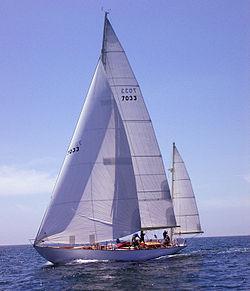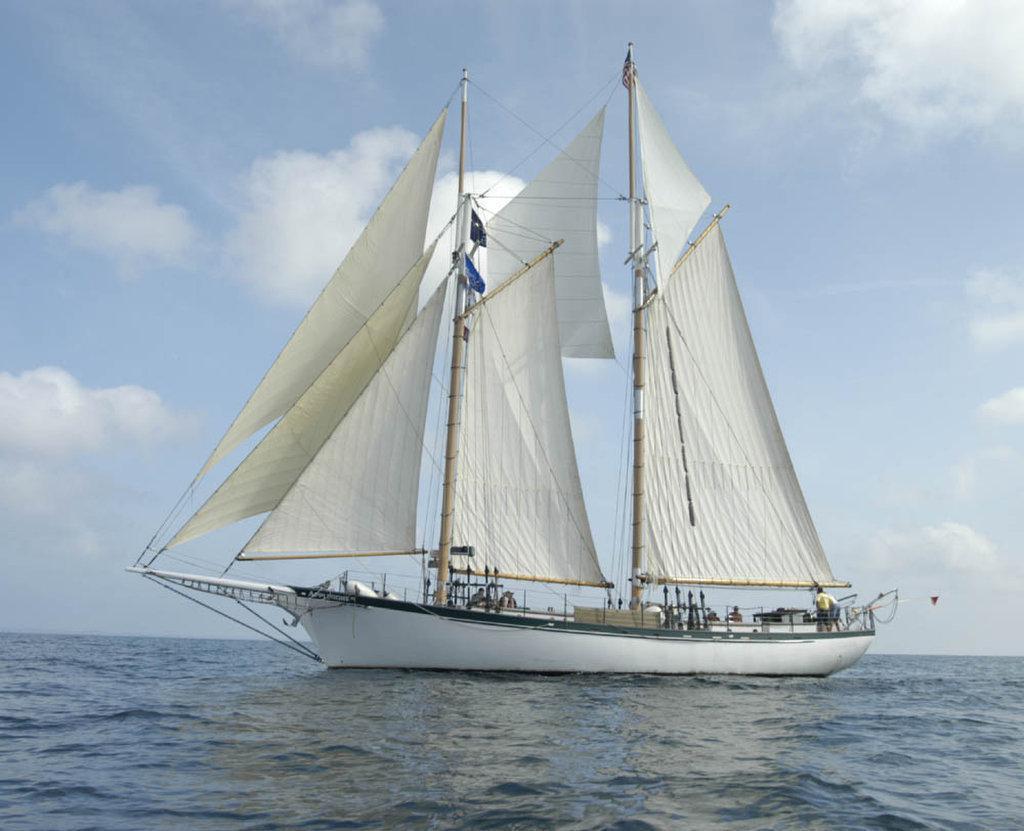The first image is the image on the left, the second image is the image on the right. Given the left and right images, does the statement "The boat in the photo on the right is flying a flag off its rearmost line." hold true? Answer yes or no. No. The first image is the image on the left, the second image is the image on the right. Analyze the images presented: Is the assertion "There are exactly three inflated sails in the image on the right." valid? Answer yes or no. No. 